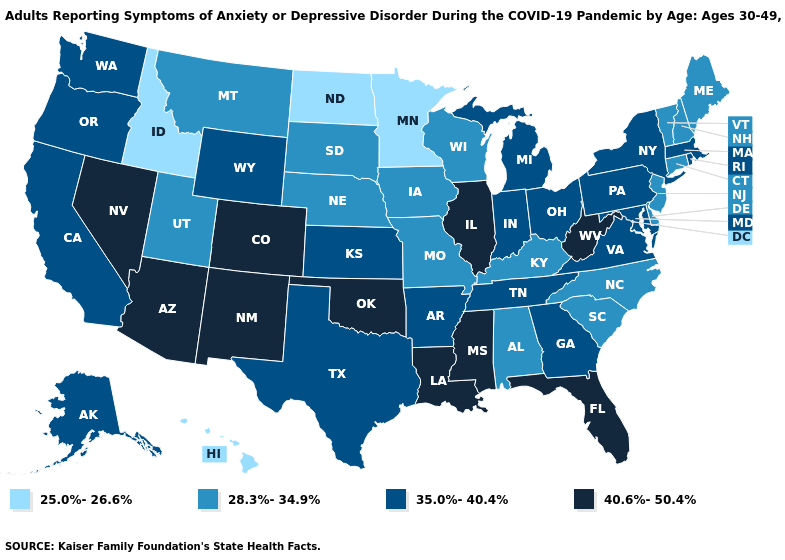What is the value of Washington?
Concise answer only. 35.0%-40.4%. What is the value of Arizona?
Answer briefly. 40.6%-50.4%. Name the states that have a value in the range 40.6%-50.4%?
Write a very short answer. Arizona, Colorado, Florida, Illinois, Louisiana, Mississippi, Nevada, New Mexico, Oklahoma, West Virginia. Name the states that have a value in the range 28.3%-34.9%?
Concise answer only. Alabama, Connecticut, Delaware, Iowa, Kentucky, Maine, Missouri, Montana, Nebraska, New Hampshire, New Jersey, North Carolina, South Carolina, South Dakota, Utah, Vermont, Wisconsin. Among the states that border New Hampshire , which have the lowest value?
Write a very short answer. Maine, Vermont. How many symbols are there in the legend?
Quick response, please. 4. Name the states that have a value in the range 40.6%-50.4%?
Short answer required. Arizona, Colorado, Florida, Illinois, Louisiana, Mississippi, Nevada, New Mexico, Oklahoma, West Virginia. Is the legend a continuous bar?
Give a very brief answer. No. Name the states that have a value in the range 25.0%-26.6%?
Quick response, please. Hawaii, Idaho, Minnesota, North Dakota. Does Minnesota have the lowest value in the MidWest?
Quick response, please. Yes. Which states have the lowest value in the South?
Answer briefly. Alabama, Delaware, Kentucky, North Carolina, South Carolina. What is the highest value in the MidWest ?
Answer briefly. 40.6%-50.4%. Does Idaho have the lowest value in the USA?
Concise answer only. Yes. Name the states that have a value in the range 40.6%-50.4%?
Concise answer only. Arizona, Colorado, Florida, Illinois, Louisiana, Mississippi, Nevada, New Mexico, Oklahoma, West Virginia. What is the value of Ohio?
Answer briefly. 35.0%-40.4%. 